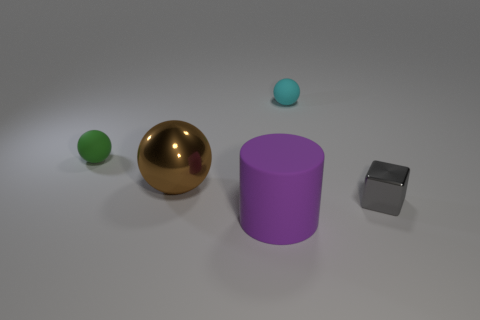What shape is the tiny rubber thing that is left of the small thing that is behind the tiny green ball?
Provide a succinct answer. Sphere. How many small things are rubber balls or green objects?
Provide a succinct answer. 2. What number of other big matte objects are the same shape as the brown thing?
Ensure brevity in your answer.  0. There is a tiny gray thing; is its shape the same as the purple rubber object that is in front of the metallic ball?
Ensure brevity in your answer.  No. How many matte objects are on the right side of the large purple rubber cylinder?
Your response must be concise. 1. Is there a green shiny cylinder of the same size as the green object?
Offer a terse response. No. Is the shape of the matte thing that is in front of the big metallic thing the same as  the small green rubber thing?
Your answer should be very brief. No. What is the color of the rubber cylinder?
Provide a short and direct response. Purple. Is there a blue rubber cylinder?
Give a very brief answer. No. There is a green thing that is the same material as the small cyan object; what size is it?
Your answer should be compact. Small. 